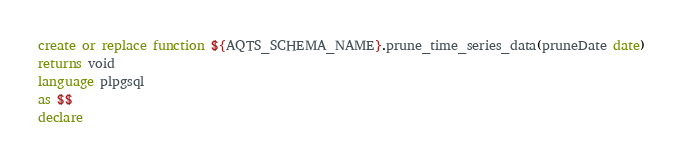<code> <loc_0><loc_0><loc_500><loc_500><_SQL_>create or replace function ${AQTS_SCHEMA_NAME}.prune_time_series_data(pruneDate date)
returns void
language plpgsql
as $$
declare</code> 